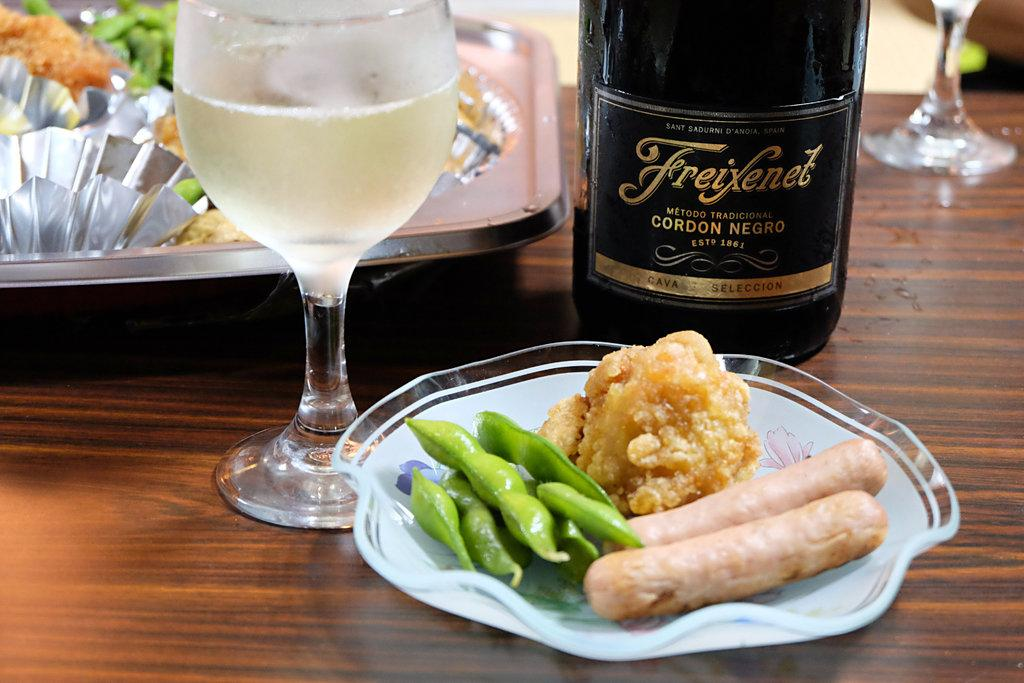<image>
Create a compact narrative representing the image presented. Some rather anaemic looking sausage sit in front of a bottle of Cava 